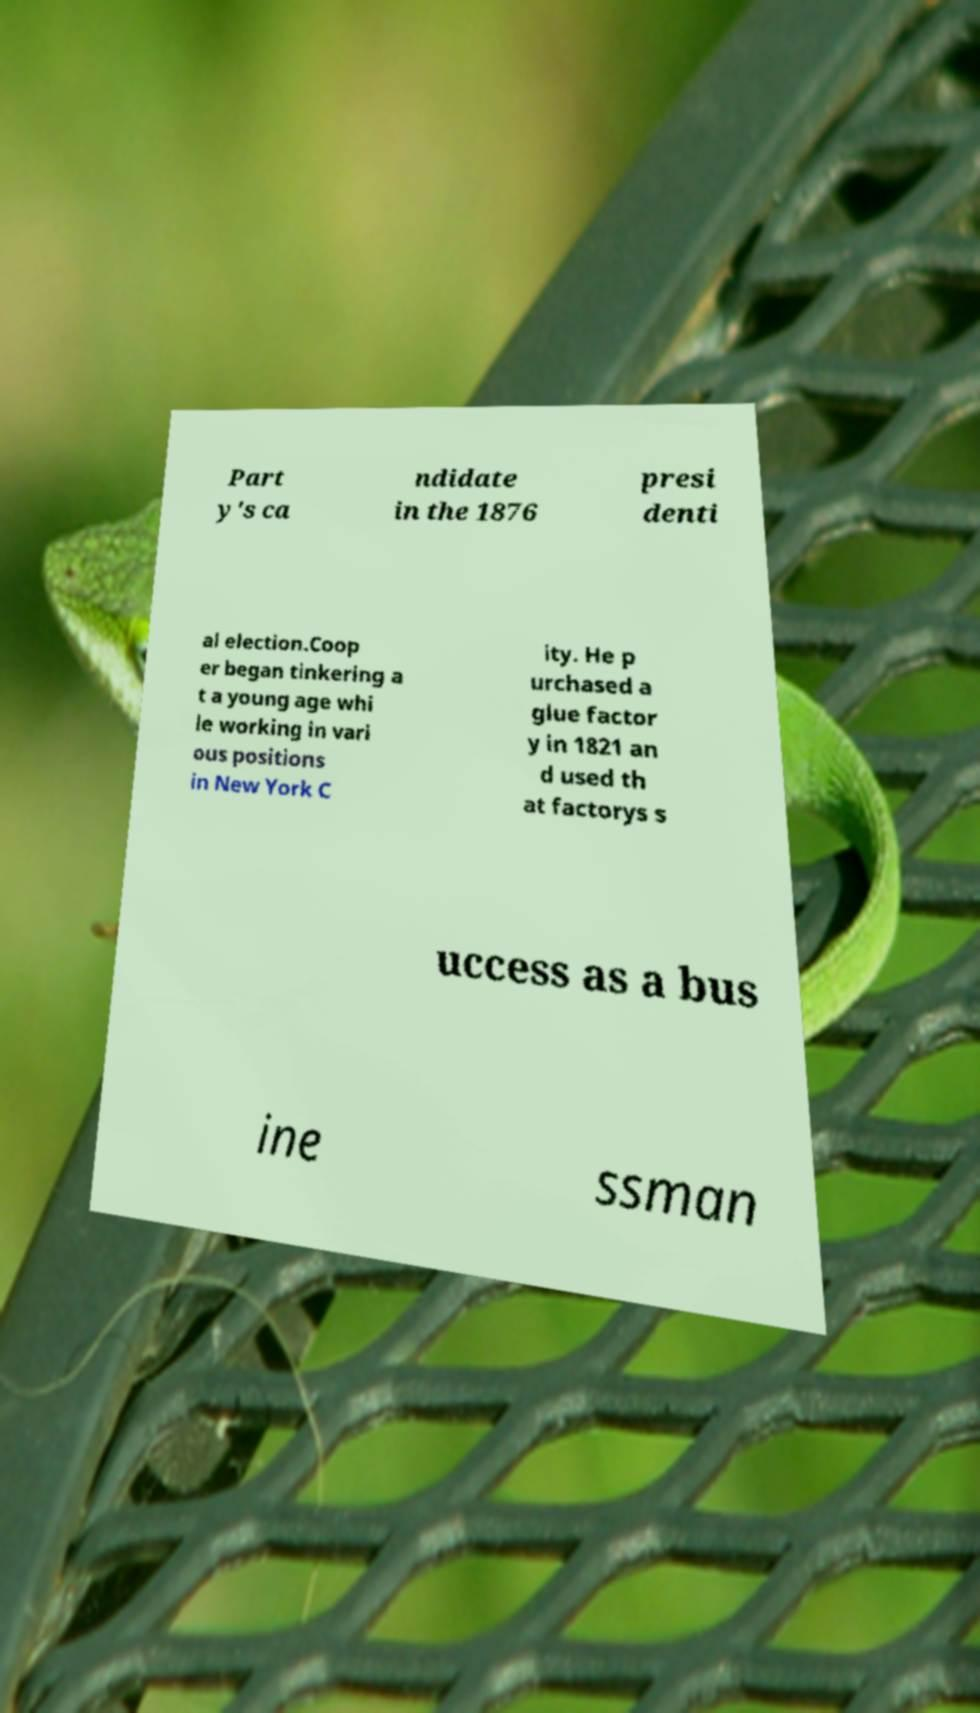For documentation purposes, I need the text within this image transcribed. Could you provide that? Part y's ca ndidate in the 1876 presi denti al election.Coop er began tinkering a t a young age whi le working in vari ous positions in New York C ity. He p urchased a glue factor y in 1821 an d used th at factorys s uccess as a bus ine ssman 